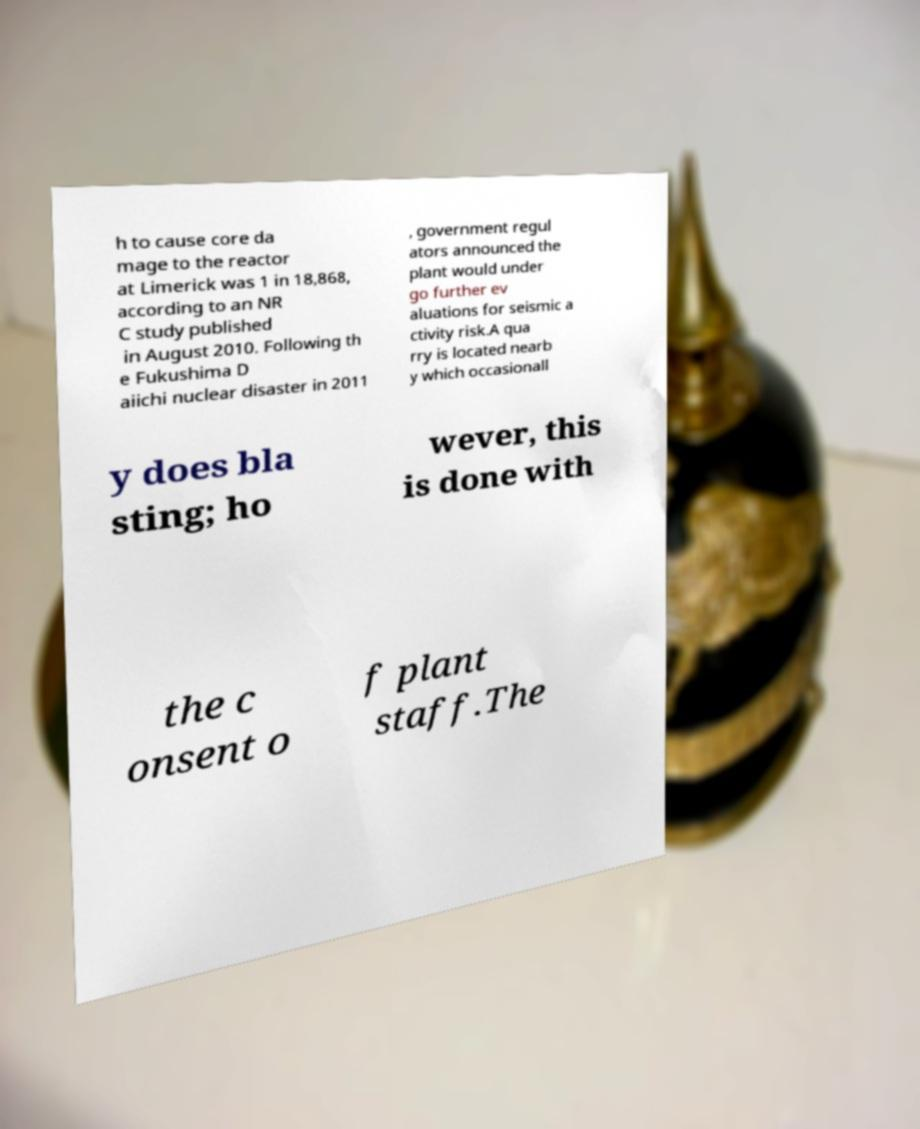Please identify and transcribe the text found in this image. h to cause core da mage to the reactor at Limerick was 1 in 18,868, according to an NR C study published in August 2010. Following th e Fukushima D aiichi nuclear disaster in 2011 , government regul ators announced the plant would under go further ev aluations for seismic a ctivity risk.A qua rry is located nearb y which occasionall y does bla sting; ho wever, this is done with the c onsent o f plant staff.The 